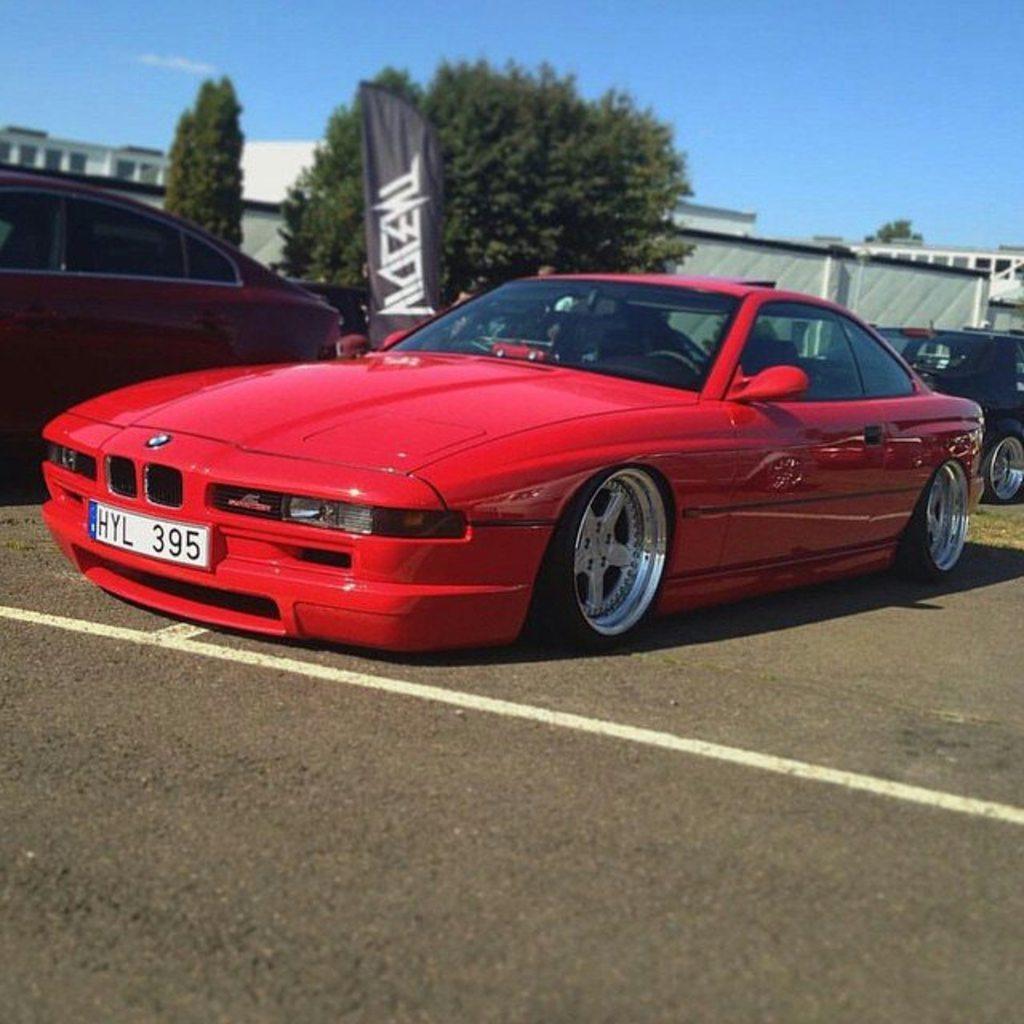Please provide a concise description of this image. In this image, I can see vehicles on the road. There are trees, buildings, and an advertising flag. In the background, there is the sky. 